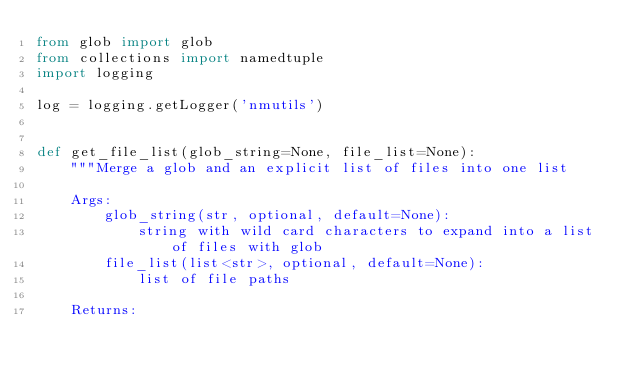<code> <loc_0><loc_0><loc_500><loc_500><_Python_>from glob import glob
from collections import namedtuple
import logging

log = logging.getLogger('nmutils')


def get_file_list(glob_string=None, file_list=None):
    """Merge a glob and an explicit list of files into one list

    Args:
        glob_string(str, optional, default=None):
            string with wild card characters to expand into a list of files with glob
        file_list(list<str>, optional, default=None):
            list of file paths

    Returns:</code> 